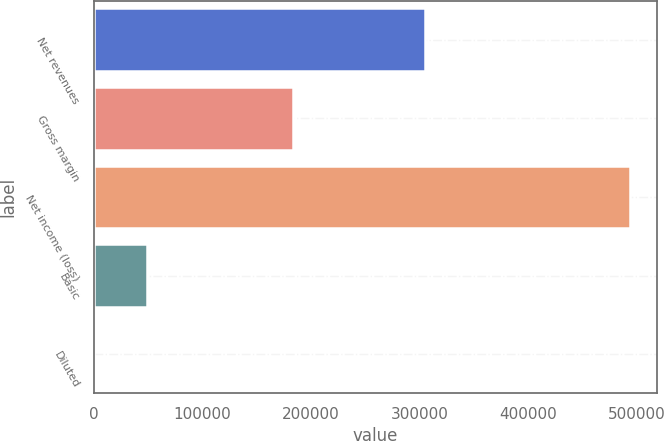<chart> <loc_0><loc_0><loc_500><loc_500><bar_chart><fcel>Net revenues<fcel>Gross margin<fcel>Net income (loss)<fcel>Basic<fcel>Diluted<nl><fcel>305514<fcel>183163<fcel>494092<fcel>49409.3<fcel>0.14<nl></chart> 